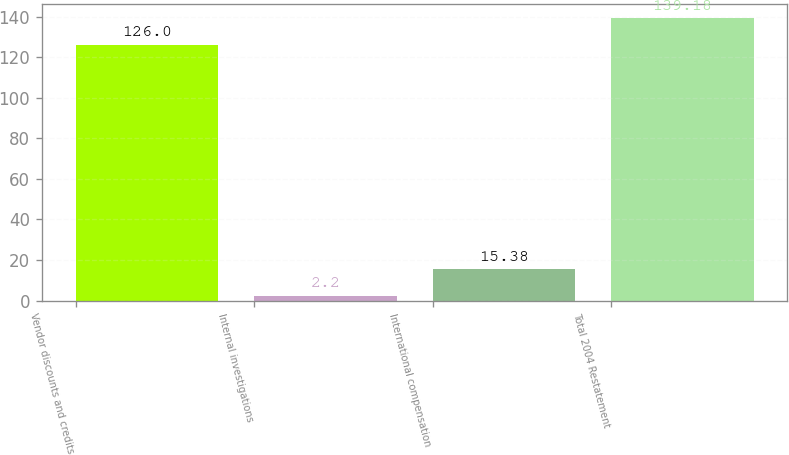Convert chart. <chart><loc_0><loc_0><loc_500><loc_500><bar_chart><fcel>Vendor discounts and credits<fcel>Internal investigations<fcel>International compensation<fcel>Total 2004 Restatement<nl><fcel>126<fcel>2.2<fcel>15.38<fcel>139.18<nl></chart> 